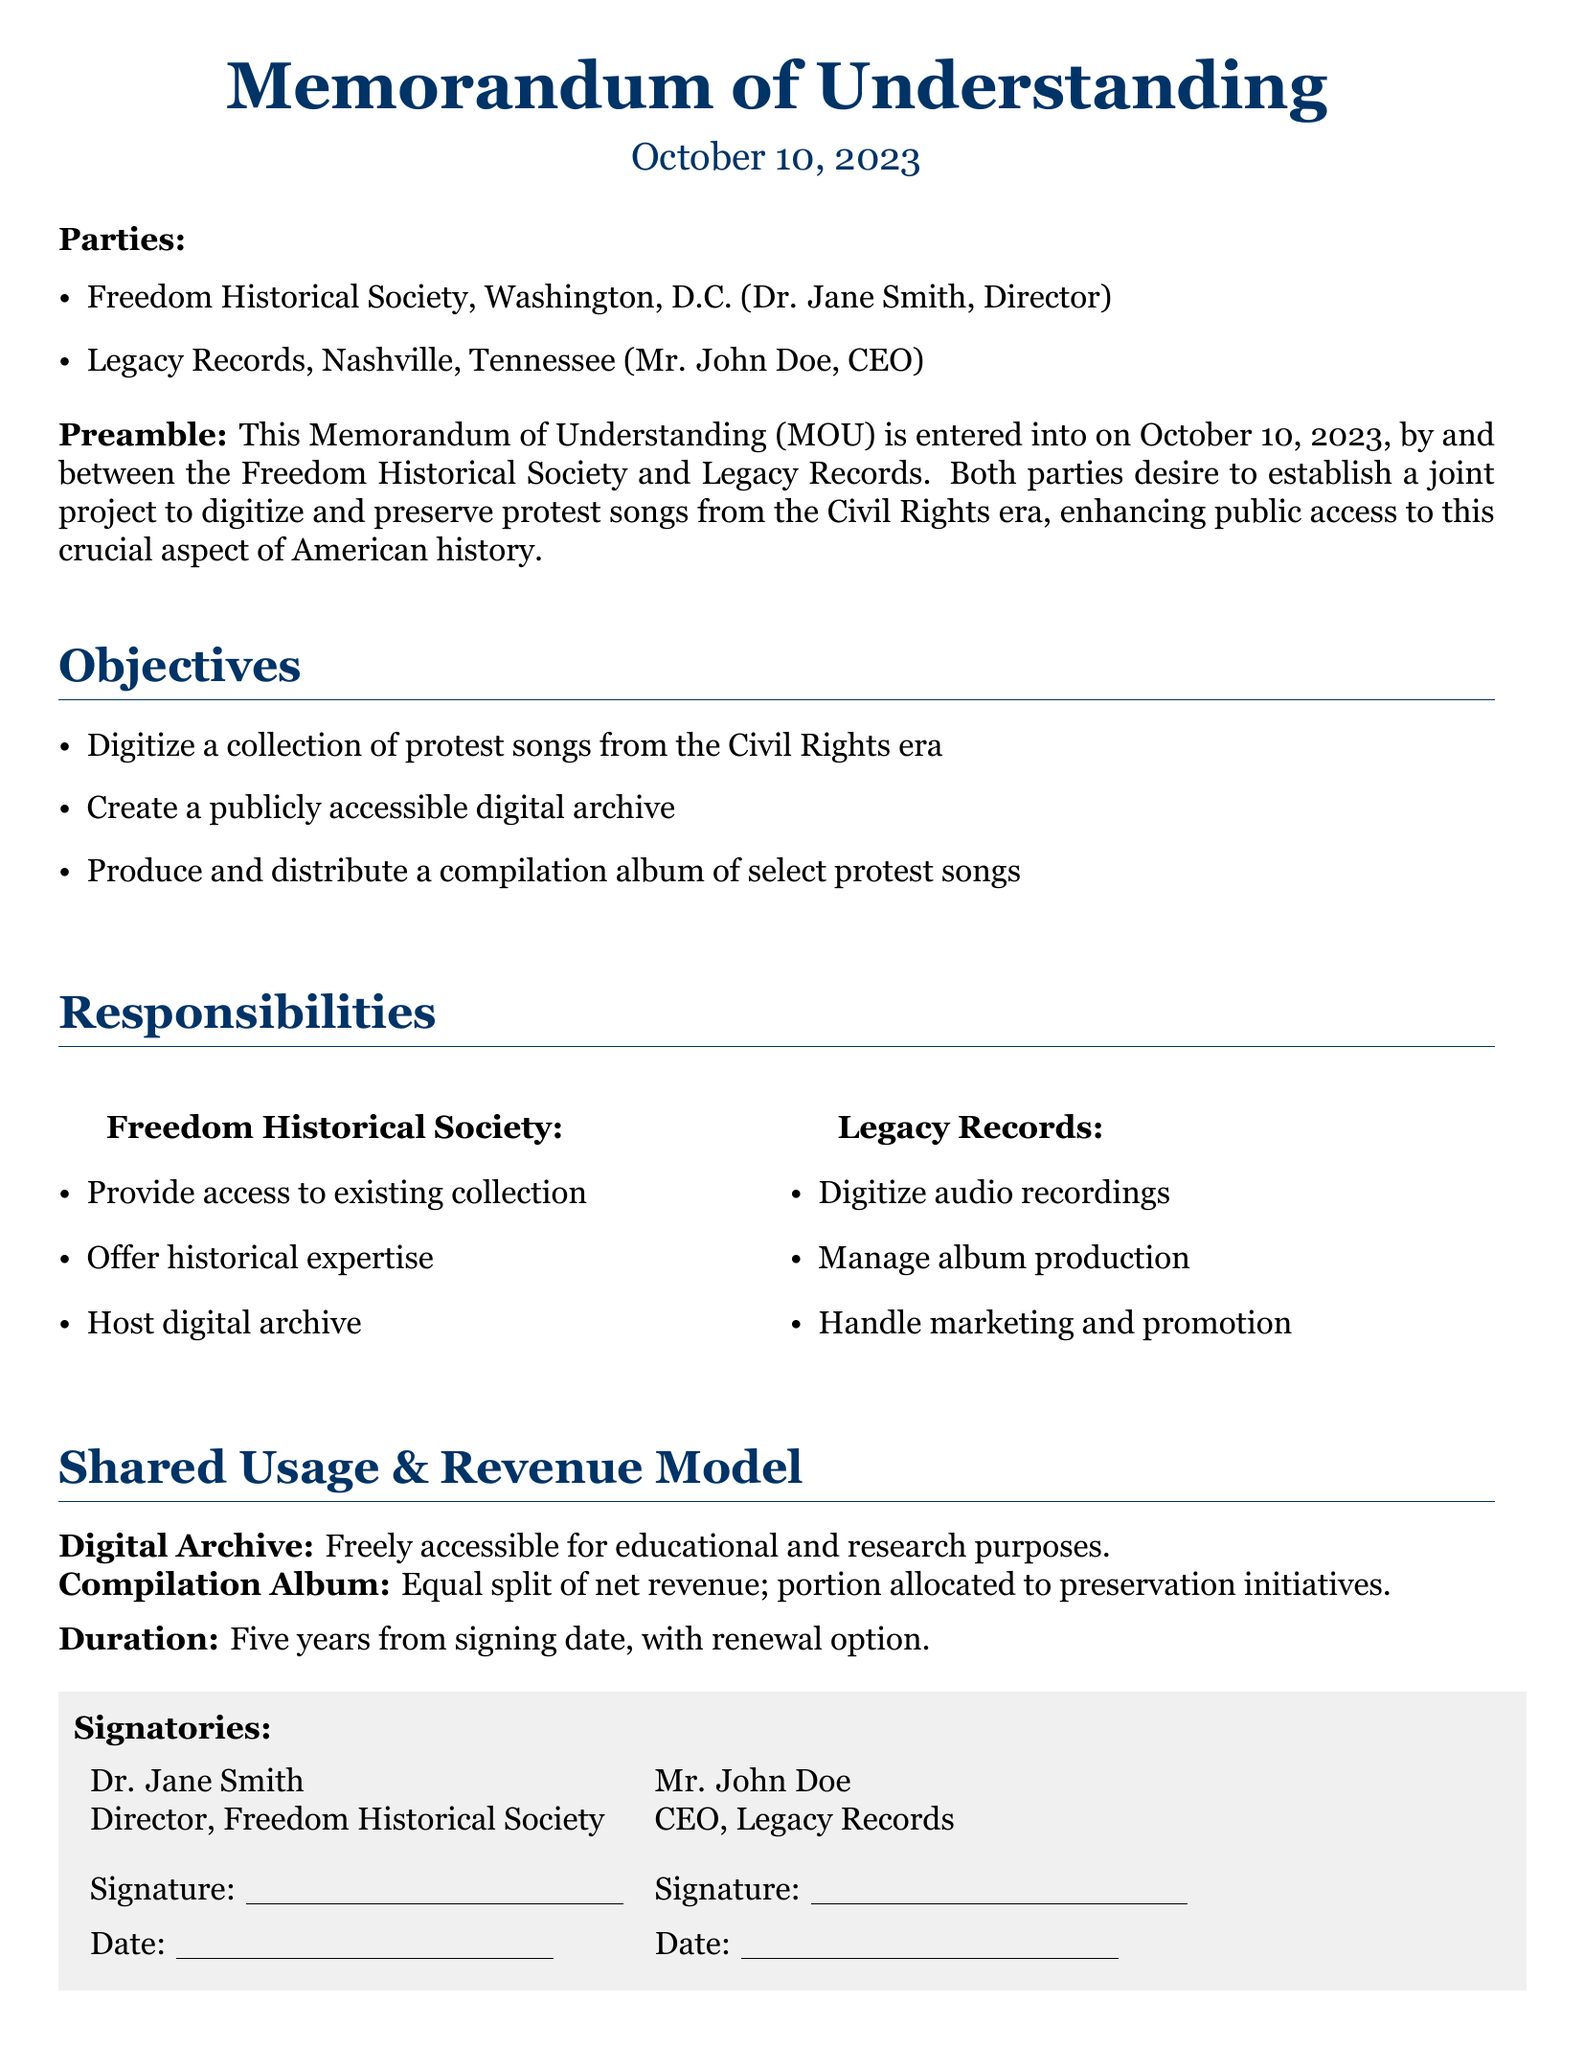What is the date of signing? The document states the signing date explicitly at the beginning.
Answer: October 10, 2023 Who is the Director of the Freedom Historical Society? The document lists Dr. Jane Smith as the Director.
Answer: Dr. Jane Smith What company is involved with the Freedom Historical Society? The document mentions Legacy Records as the partner organization.
Answer: Legacy Records How many years is the duration of the MOU? The document specifies the duration in the "Duration" section.
Answer: Five years What is the primary purpose of the joint project? The Preamble of the document outlines the main goal of the project.
Answer: Digitize and preserve protest songs What is the revenue split for the compilation album? The Shared Usage & Revenue Model section provides specific details about revenue sharing.
Answer: Equal split What will the Freedom Historical Society provide? The document lists the responsibilities of the Freedom Historical Society.
Answer: Access to existing collection What responsibilities does Legacy Records have? The document outlines Legacy Records' duties in a specific section.
Answer: Digitize audio recordings What will the digital archive be used for? The Shared Usage & Revenue Model section mentions the purpose of the digital archive.
Answer: Educational and research purposes 